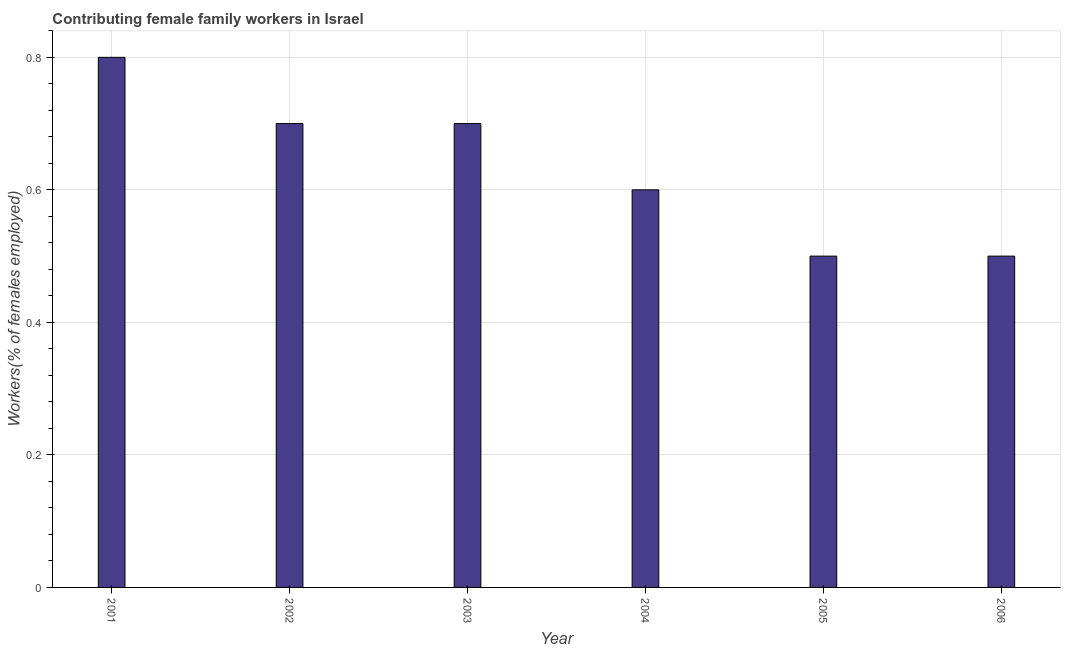Does the graph contain any zero values?
Your answer should be compact. No. What is the title of the graph?
Your answer should be very brief. Contributing female family workers in Israel. What is the label or title of the Y-axis?
Your response must be concise. Workers(% of females employed). What is the contributing female family workers in 2002?
Your response must be concise. 0.7. Across all years, what is the maximum contributing female family workers?
Make the answer very short. 0.8. Across all years, what is the minimum contributing female family workers?
Offer a very short reply. 0.5. In which year was the contributing female family workers minimum?
Your response must be concise. 2005. What is the sum of the contributing female family workers?
Provide a succinct answer. 3.8. What is the average contributing female family workers per year?
Offer a very short reply. 0.63. What is the median contributing female family workers?
Make the answer very short. 0.65. What is the ratio of the contributing female family workers in 2002 to that in 2004?
Your answer should be very brief. 1.17. Is the contributing female family workers in 2003 less than that in 2004?
Make the answer very short. No. Is the difference between the contributing female family workers in 2003 and 2004 greater than the difference between any two years?
Give a very brief answer. No. Is the sum of the contributing female family workers in 2001 and 2005 greater than the maximum contributing female family workers across all years?
Provide a short and direct response. Yes. In how many years, is the contributing female family workers greater than the average contributing female family workers taken over all years?
Your answer should be very brief. 3. Are all the bars in the graph horizontal?
Give a very brief answer. No. What is the difference between two consecutive major ticks on the Y-axis?
Provide a short and direct response. 0.2. What is the Workers(% of females employed) in 2001?
Your answer should be compact. 0.8. What is the Workers(% of females employed) of 2002?
Your answer should be very brief. 0.7. What is the Workers(% of females employed) of 2003?
Provide a short and direct response. 0.7. What is the Workers(% of females employed) of 2004?
Give a very brief answer. 0.6. What is the Workers(% of females employed) of 2005?
Provide a short and direct response. 0.5. What is the Workers(% of females employed) of 2006?
Ensure brevity in your answer.  0.5. What is the difference between the Workers(% of females employed) in 2001 and 2002?
Give a very brief answer. 0.1. What is the difference between the Workers(% of females employed) in 2001 and 2003?
Keep it short and to the point. 0.1. What is the difference between the Workers(% of females employed) in 2001 and 2004?
Give a very brief answer. 0.2. What is the difference between the Workers(% of females employed) in 2001 and 2005?
Ensure brevity in your answer.  0.3. What is the difference between the Workers(% of females employed) in 2001 and 2006?
Make the answer very short. 0.3. What is the difference between the Workers(% of females employed) in 2002 and 2004?
Provide a short and direct response. 0.1. What is the difference between the Workers(% of females employed) in 2002 and 2005?
Your response must be concise. 0.2. What is the difference between the Workers(% of females employed) in 2003 and 2004?
Provide a short and direct response. 0.1. What is the difference between the Workers(% of females employed) in 2003 and 2005?
Keep it short and to the point. 0.2. What is the difference between the Workers(% of females employed) in 2004 and 2005?
Make the answer very short. 0.1. What is the difference between the Workers(% of females employed) in 2004 and 2006?
Your response must be concise. 0.1. What is the difference between the Workers(% of females employed) in 2005 and 2006?
Your response must be concise. 0. What is the ratio of the Workers(% of females employed) in 2001 to that in 2002?
Offer a very short reply. 1.14. What is the ratio of the Workers(% of females employed) in 2001 to that in 2003?
Ensure brevity in your answer.  1.14. What is the ratio of the Workers(% of females employed) in 2001 to that in 2004?
Keep it short and to the point. 1.33. What is the ratio of the Workers(% of females employed) in 2001 to that in 2005?
Ensure brevity in your answer.  1.6. What is the ratio of the Workers(% of females employed) in 2002 to that in 2004?
Provide a short and direct response. 1.17. What is the ratio of the Workers(% of females employed) in 2003 to that in 2004?
Give a very brief answer. 1.17. What is the ratio of the Workers(% of females employed) in 2004 to that in 2006?
Your response must be concise. 1.2. What is the ratio of the Workers(% of females employed) in 2005 to that in 2006?
Your answer should be compact. 1. 